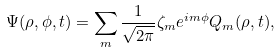<formula> <loc_0><loc_0><loc_500><loc_500>\Psi ( \rho , \phi , t ) = \sum _ { m } \frac { 1 } { \sqrt { 2 \pi } } \zeta _ { m } e ^ { i m \phi } Q _ { m } ( \rho , t ) ,</formula> 